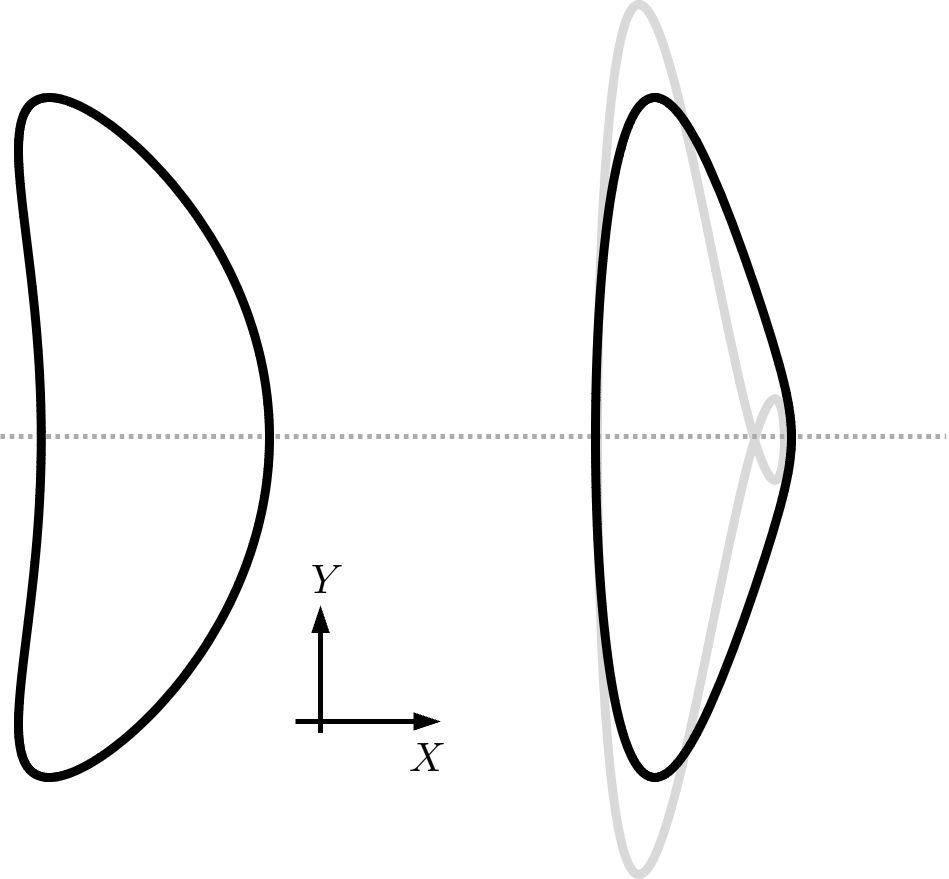What would happen to the perimeter of the original shape after this transformation? Similar to the area, the perimeter of the shape also changes due to the dilation transformation. The perimeter is either increased or decreased in direct proportion to the scale factor. For example, if the shape is scaled up by a factor of two, the perimeter will also double. 